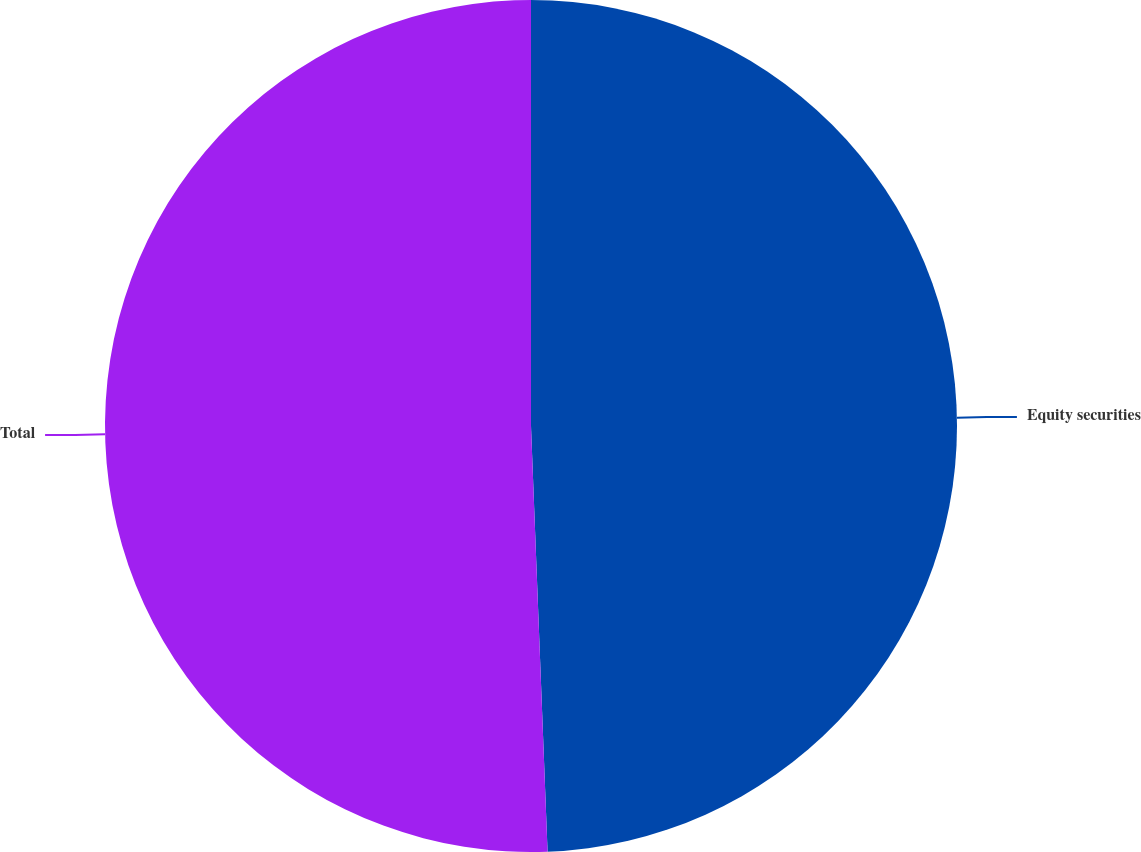<chart> <loc_0><loc_0><loc_500><loc_500><pie_chart><fcel>Equity securities<fcel>Total<nl><fcel>49.38%<fcel>50.62%<nl></chart> 